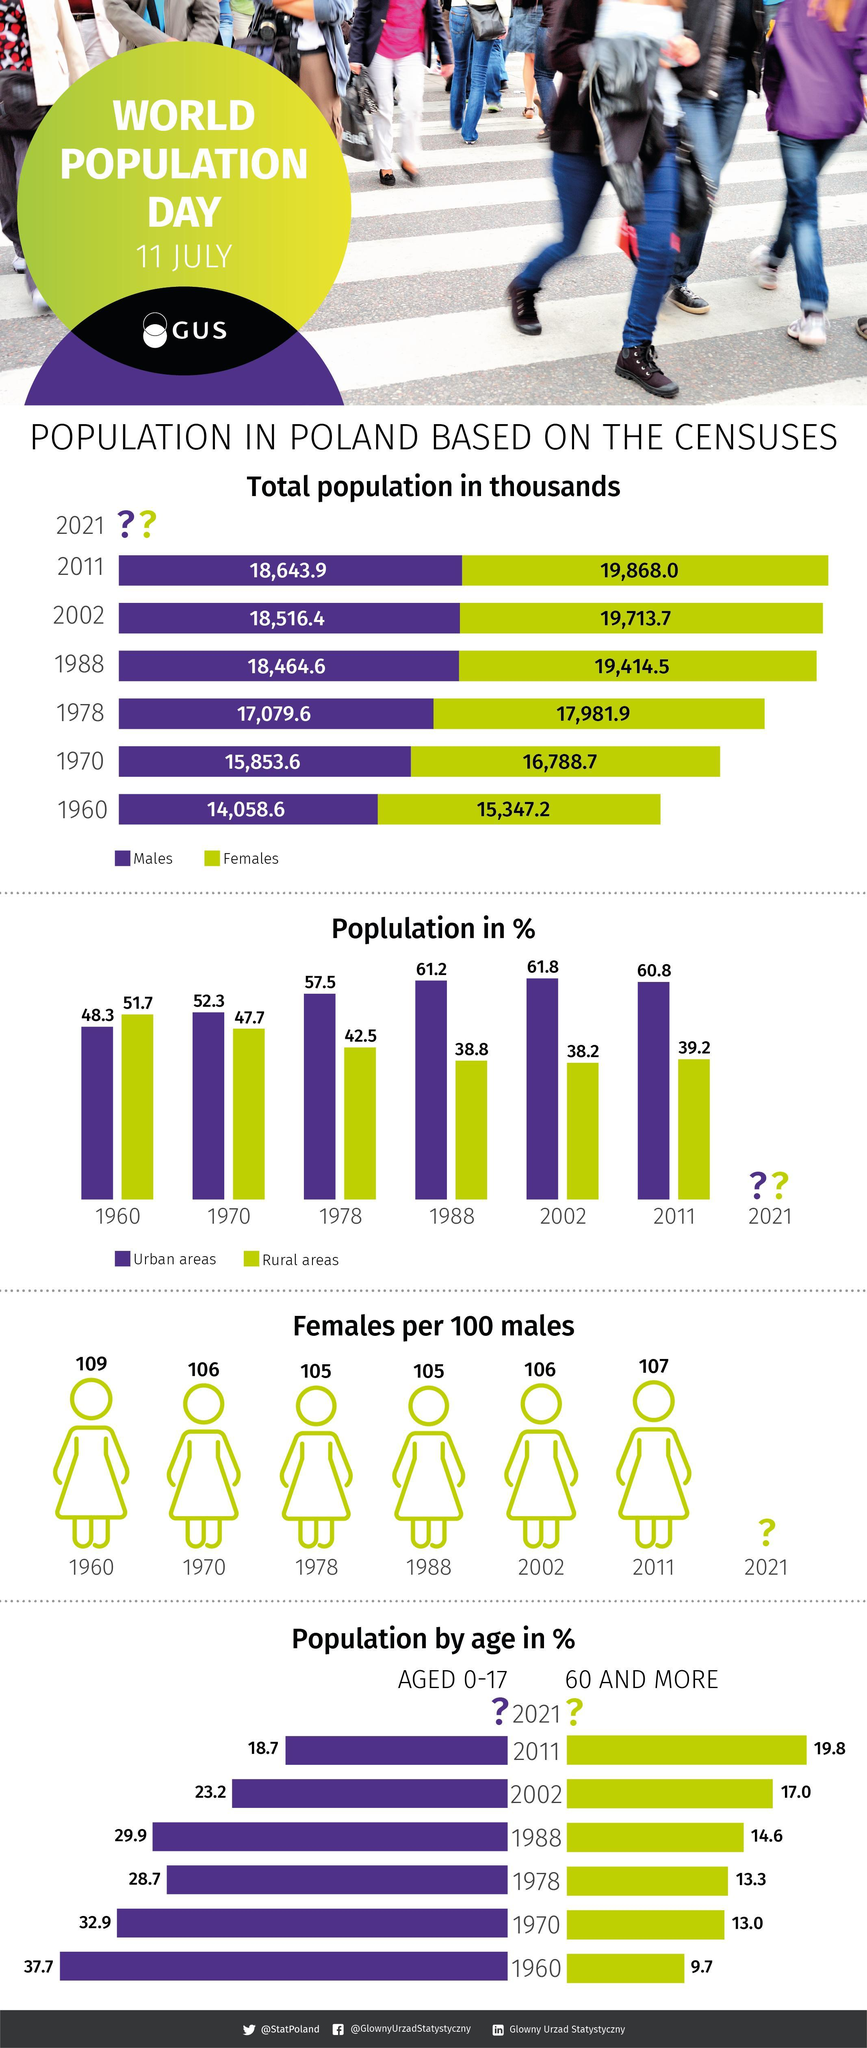What is the total population of Poland in 2011?
Answer the question with a short phrase. 38,511.9 What is the number of females in Poland in 1970? 16,788.7 In which year the population in the urban area is the second-highest? 1988 In which year the population in the rural area is the second-highest? 1970 What is the number of females in Poland in 1960? 15,347.2 